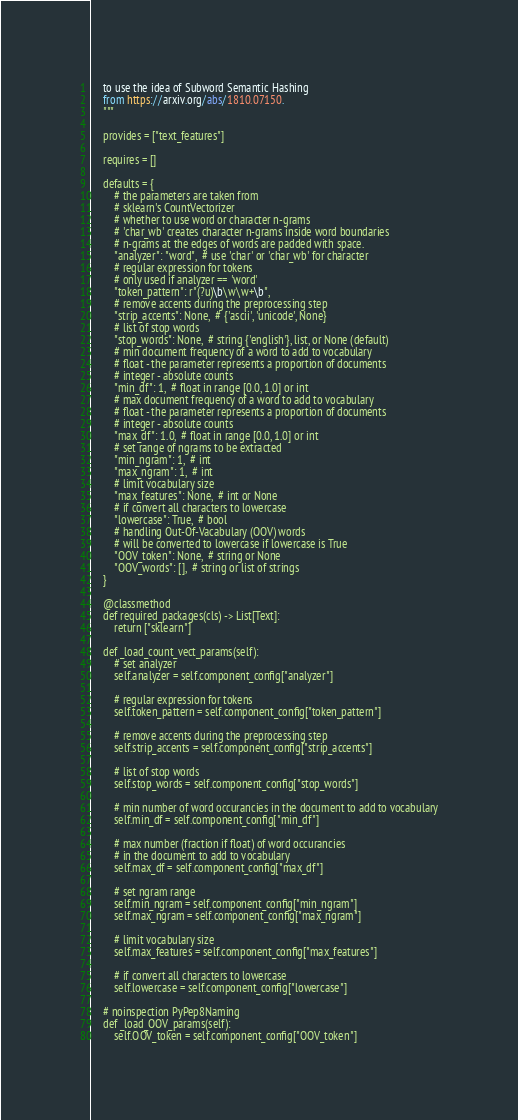Convert code to text. <code><loc_0><loc_0><loc_500><loc_500><_Python_>    to use the idea of Subword Semantic Hashing
    from https://arxiv.org/abs/1810.07150.
    """

    provides = ["text_features"]

    requires = []

    defaults = {
        # the parameters are taken from
        # sklearn's CountVectorizer
        # whether to use word or character n-grams
        # 'char_wb' creates character n-grams inside word boundaries
        # n-grams at the edges of words are padded with space.
        "analyzer": "word",  # use 'char' or 'char_wb' for character
        # regular expression for tokens
        # only used if analyzer == 'word'
        "token_pattern": r"(?u)\b\w\w+\b",
        # remove accents during the preprocessing step
        "strip_accents": None,  # {'ascii', 'unicode', None}
        # list of stop words
        "stop_words": None,  # string {'english'}, list, or None (default)
        # min document frequency of a word to add to vocabulary
        # float - the parameter represents a proportion of documents
        # integer - absolute counts
        "min_df": 1,  # float in range [0.0, 1.0] or int
        # max document frequency of a word to add to vocabulary
        # float - the parameter represents a proportion of documents
        # integer - absolute counts
        "max_df": 1.0,  # float in range [0.0, 1.0] or int
        # set range of ngrams to be extracted
        "min_ngram": 1,  # int
        "max_ngram": 1,  # int
        # limit vocabulary size
        "max_features": None,  # int or None
        # if convert all characters to lowercase
        "lowercase": True,  # bool
        # handling Out-Of-Vacabulary (OOV) words
        # will be converted to lowercase if lowercase is True
        "OOV_token": None,  # string or None
        "OOV_words": [],  # string or list of strings
    }

    @classmethod
    def required_packages(cls) -> List[Text]:
        return ["sklearn"]

    def _load_count_vect_params(self):
        # set analyzer
        self.analyzer = self.component_config["analyzer"]

        # regular expression for tokens
        self.token_pattern = self.component_config["token_pattern"]

        # remove accents during the preprocessing step
        self.strip_accents = self.component_config["strip_accents"]

        # list of stop words
        self.stop_words = self.component_config["stop_words"]

        # min number of word occurancies in the document to add to vocabulary
        self.min_df = self.component_config["min_df"]

        # max number (fraction if float) of word occurancies
        # in the document to add to vocabulary
        self.max_df = self.component_config["max_df"]

        # set ngram range
        self.min_ngram = self.component_config["min_ngram"]
        self.max_ngram = self.component_config["max_ngram"]

        # limit vocabulary size
        self.max_features = self.component_config["max_features"]

        # if convert all characters to lowercase
        self.lowercase = self.component_config["lowercase"]

    # noinspection PyPep8Naming
    def _load_OOV_params(self):
        self.OOV_token = self.component_config["OOV_token"]
</code> 